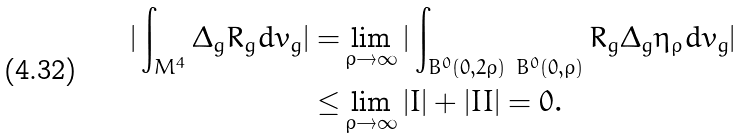<formula> <loc_0><loc_0><loc_500><loc_500>| \int _ { M ^ { 4 } } \Delta _ { g } R _ { g } d v _ { g } | = & \lim _ { \rho \rightarrow \infty } | \int _ { B ^ { 0 } ( 0 , 2 \rho ) \ B ^ { 0 } ( 0 , \rho ) } R _ { g } \Delta _ { g } \eta _ { \rho } d v _ { g } | \\ \leq & \lim _ { \rho \rightarrow \infty } | I | + | I I | = 0 . \\</formula> 